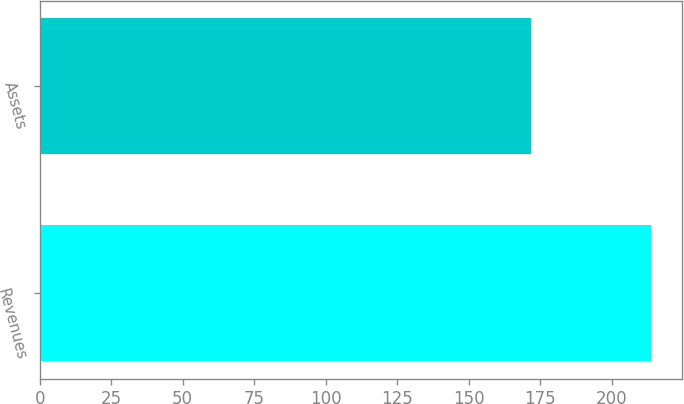Convert chart to OTSL. <chart><loc_0><loc_0><loc_500><loc_500><bar_chart><fcel>Revenues<fcel>Assets<nl><fcel>213.7<fcel>171.6<nl></chart> 